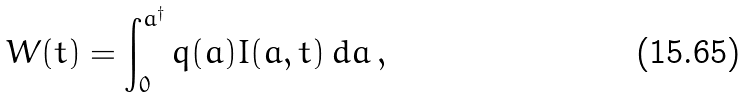Convert formula to latex. <formula><loc_0><loc_0><loc_500><loc_500>W ( t ) = \int _ { 0 } ^ { a ^ { \dagger } } q ( a ) I ( a , t ) \, d a \, ,</formula> 